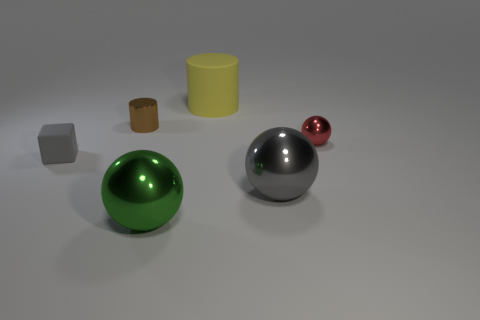How many objects are shiny cylinders or rubber objects that are behind the shiny cylinder?
Your response must be concise. 2. Are there fewer tiny red objects than gray things?
Ensure brevity in your answer.  Yes. The rubber object behind the matte object in front of the small metal thing that is behind the red metal object is what color?
Provide a short and direct response. Yellow. Do the big green thing and the red thing have the same material?
Give a very brief answer. Yes. There is a small brown object; what number of brown metal cylinders are left of it?
Offer a very short reply. 0. The red object that is the same shape as the big green thing is what size?
Provide a succinct answer. Small. What number of red things are small metal spheres or matte blocks?
Offer a terse response. 1. There is a metallic ball in front of the gray ball; how many big objects are behind it?
Your response must be concise. 2. How many other things are there of the same shape as the tiny gray thing?
Your answer should be compact. 0. There is a big sphere that is the same color as the small rubber block; what is its material?
Provide a short and direct response. Metal. 